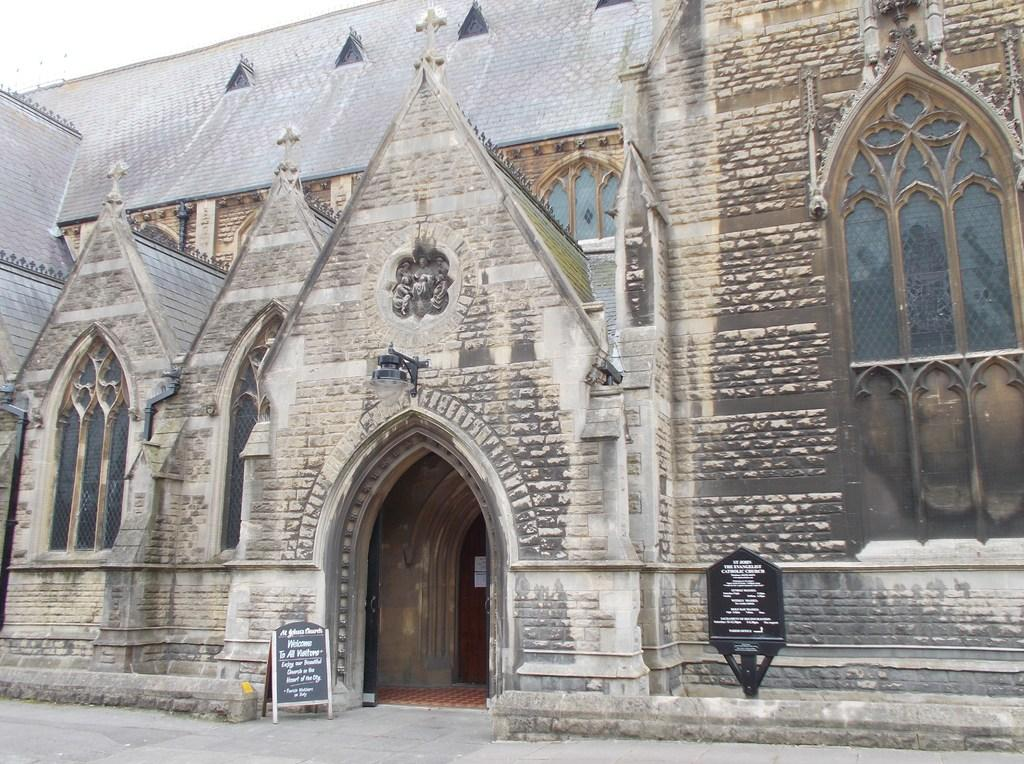What type of structure is present in the image? There is a building in the image. What else can be seen in the image besides the building? There are boards visible in the image. What can be seen in the background of the image? The sky is visible in the background of the image. What type of jeans is hanging from the heart in the image? There is no heart or jeans present in the image. 